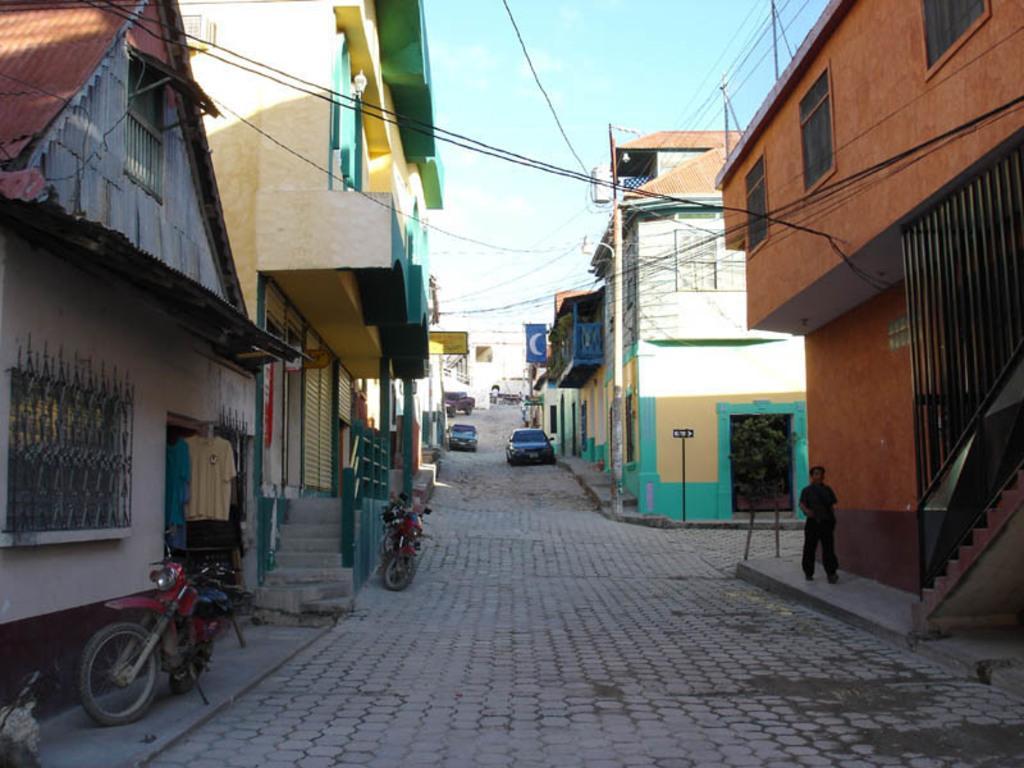How would you summarize this image in a sentence or two? In this image we can see vehicles on the pathway. On the both sides of the image, we can see buildings, stairs and wires. At the top of the image, we can see the sky. On the right side of the image, we can see a plant and a person. 